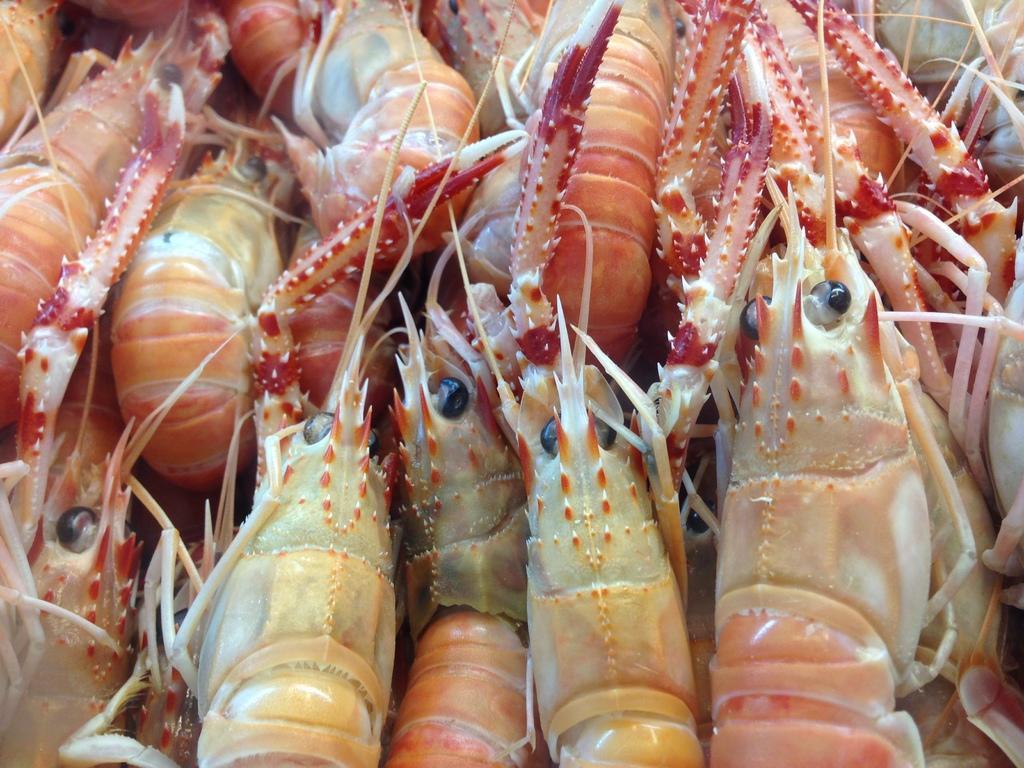Please provide a concise description of this image. In this picture I can see prawns. 